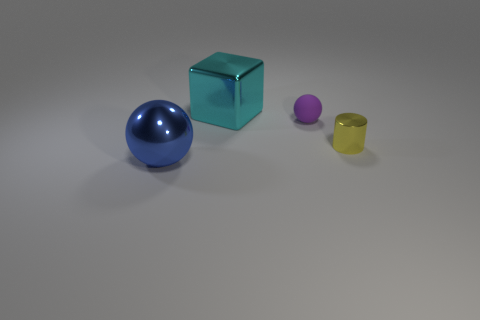The big object in front of the big metallic object behind the blue sphere is made of what material?
Make the answer very short. Metal. Are there an equal number of tiny yellow cylinders on the left side of the small ball and metal objects?
Keep it short and to the point. No. Is there any other thing that has the same material as the small purple sphere?
Make the answer very short. No. How many metallic things are right of the purple ball and on the left side of the small yellow object?
Provide a succinct answer. 0. What number of other things are there of the same shape as the small shiny object?
Offer a terse response. 0. Is the number of shiny things that are behind the small purple object greater than the number of large blue matte cubes?
Keep it short and to the point. Yes. The metallic object on the right side of the purple matte sphere is what color?
Ensure brevity in your answer.  Yellow. What number of metallic objects are red balls or small purple balls?
Offer a very short reply. 0. Are there any tiny cylinders that are in front of the ball that is behind the large metallic thing that is in front of the small matte thing?
Your answer should be very brief. Yes. There is a cyan shiny cube; how many big metallic balls are behind it?
Give a very brief answer. 0. 